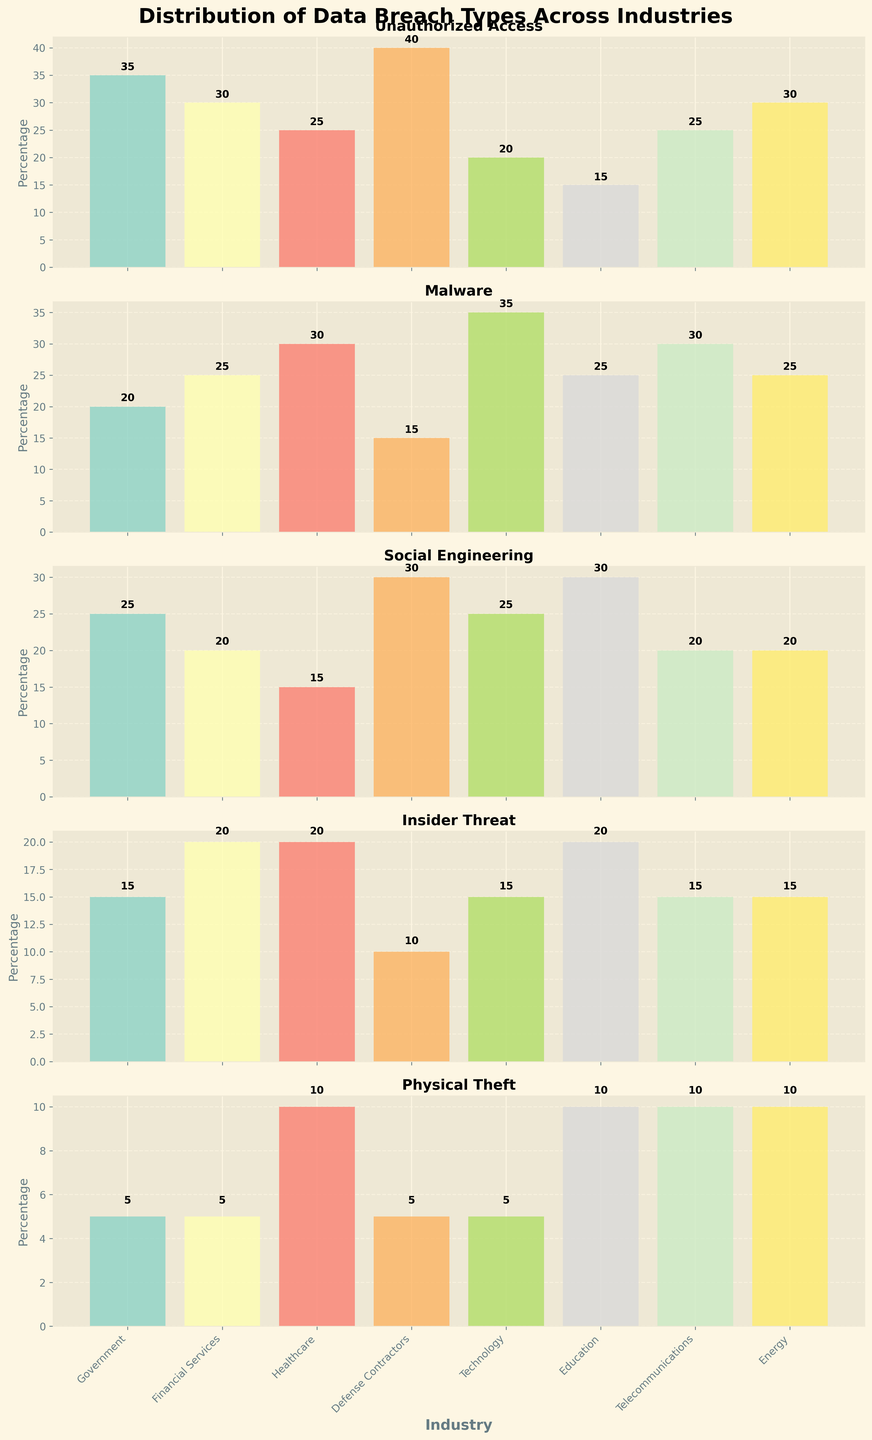What's the title of the plot? The title of the plot is placed at the top, summarizing the subject of the plot.
Answer: Distribution of Data Breach Types Across Industries Which breach type has the highest percentage in Government industry? Look at the bar height for each breach type in the Government subplot; the highest bar represents "Unauthorized Access" with 35%.
Answer: Unauthorized Access What are the total percentages of Unauthorized Access and Social Engineering breaches in Financial Services? Sum the percentages listed for Unauthorized Access and Social Engineering breaches in Financial Services: 30 + 20 = 50.
Answer: 50 In which industry does Physical Theft have the highest percentage? Compare the bar heights of Physical Theft across all industry subplots; the highest bar is in the Healthcare and Education industry with 10%.
Answer: Healthcare and Education Which two industries have equal percentages of Insider Threat breaches? Compare the bar heights of Insider Threat across all industries; Financial Services and Healthcare both show bars of height 20.
Answer: Financial Services and Healthcare Which breach type shows the most consistent percentage across all industries? Look for the breach type with the least variation in bar heights across subplots; Physical Theft bars are generally close in value.
Answer: Physical Theft What's the average percentage of Malware breaches across Technology and Telecommunications? Sum the percentages of Malware breaches in Technology and Telecommunications, then divide by 2: (35+30)/2 = 32.5.
Answer: 32.5 Which industry has the smallest percentage for any breach type and what is that percentage? Identify the shortest bar in any subplot; Government has the shortest bar for Physical Theft with 5%.
Answer: Government, 5 Are Unauthorized Access breaches more prevalent in Defense Contractors or Energy? Compare the Unauthorized Access bars between Defense Contractors and Energy; Defense Contractors has a higher percentage (40 vs. 30).
Answer: Defense Contractors 